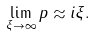Convert formula to latex. <formula><loc_0><loc_0><loc_500><loc_500>\lim _ { \xi \rightarrow \infty } p \approx i \xi .</formula> 